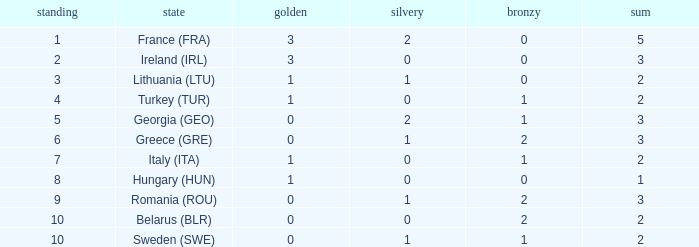What's the total of Sweden (SWE) having less than 1 silver? None. 